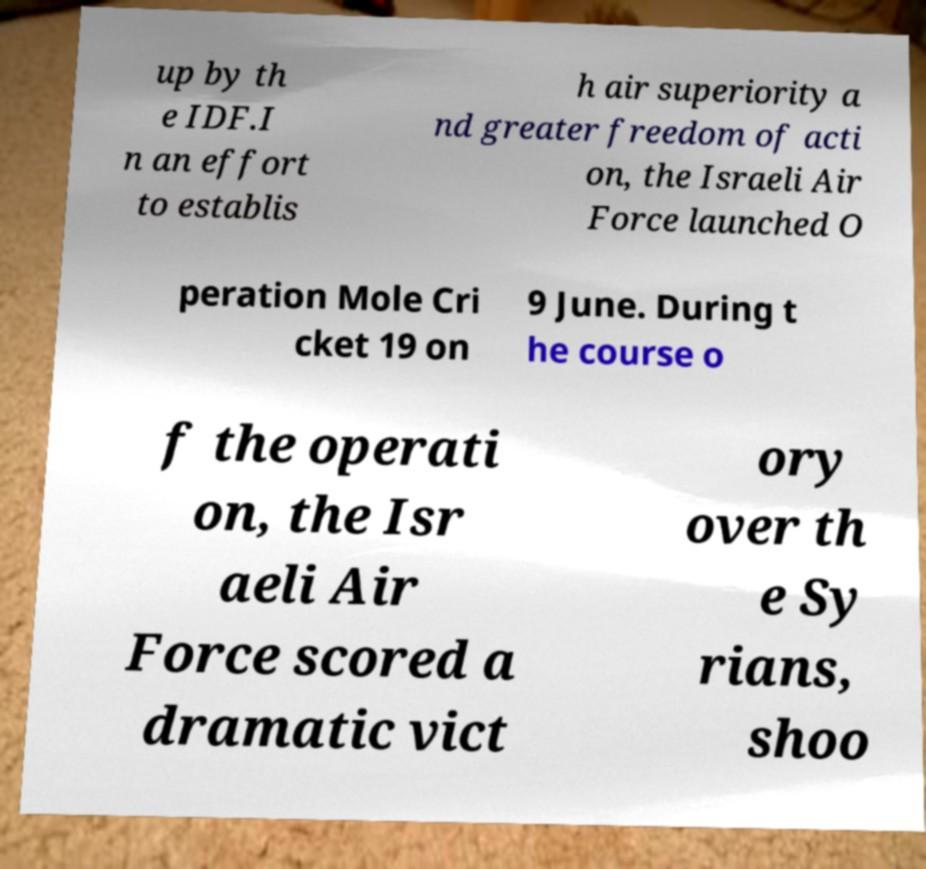For documentation purposes, I need the text within this image transcribed. Could you provide that? up by th e IDF.I n an effort to establis h air superiority a nd greater freedom of acti on, the Israeli Air Force launched O peration Mole Cri cket 19 on 9 June. During t he course o f the operati on, the Isr aeli Air Force scored a dramatic vict ory over th e Sy rians, shoo 